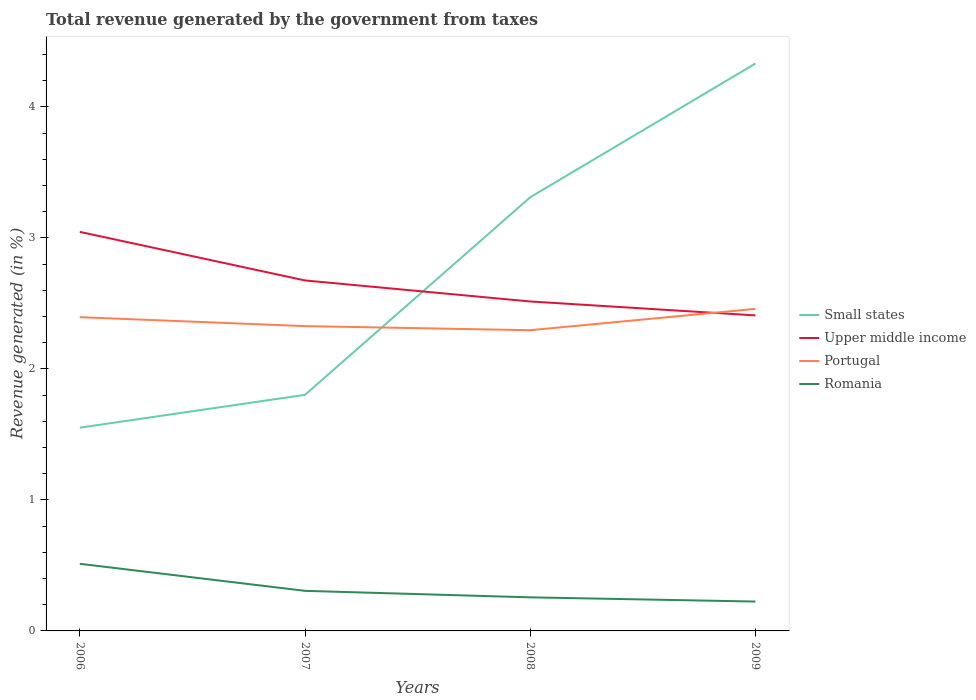Across all years, what is the maximum total revenue generated in Portugal?
Offer a terse response. 2.3. What is the total total revenue generated in Portugal in the graph?
Keep it short and to the point. -0.06. What is the difference between the highest and the second highest total revenue generated in Small states?
Offer a terse response. 2.78. What is the difference between the highest and the lowest total revenue generated in Romania?
Ensure brevity in your answer.  1. Is the total revenue generated in Upper middle income strictly greater than the total revenue generated in Romania over the years?
Your answer should be compact. No. What is the difference between two consecutive major ticks on the Y-axis?
Offer a very short reply. 1. Does the graph contain any zero values?
Your response must be concise. No. Does the graph contain grids?
Your answer should be very brief. No. Where does the legend appear in the graph?
Your answer should be very brief. Center right. How many legend labels are there?
Your answer should be compact. 4. How are the legend labels stacked?
Ensure brevity in your answer.  Vertical. What is the title of the graph?
Your response must be concise. Total revenue generated by the government from taxes. Does "Faeroe Islands" appear as one of the legend labels in the graph?
Your answer should be very brief. No. What is the label or title of the Y-axis?
Offer a very short reply. Revenue generated (in %). What is the Revenue generated (in %) of Small states in 2006?
Provide a succinct answer. 1.55. What is the Revenue generated (in %) of Upper middle income in 2006?
Give a very brief answer. 3.05. What is the Revenue generated (in %) of Portugal in 2006?
Keep it short and to the point. 2.39. What is the Revenue generated (in %) in Romania in 2006?
Your answer should be very brief. 0.51. What is the Revenue generated (in %) of Small states in 2007?
Keep it short and to the point. 1.8. What is the Revenue generated (in %) in Upper middle income in 2007?
Your answer should be very brief. 2.68. What is the Revenue generated (in %) in Portugal in 2007?
Give a very brief answer. 2.33. What is the Revenue generated (in %) of Romania in 2007?
Your answer should be very brief. 0.31. What is the Revenue generated (in %) in Small states in 2008?
Your response must be concise. 3.31. What is the Revenue generated (in %) of Upper middle income in 2008?
Keep it short and to the point. 2.51. What is the Revenue generated (in %) of Portugal in 2008?
Your answer should be very brief. 2.3. What is the Revenue generated (in %) in Romania in 2008?
Offer a very short reply. 0.26. What is the Revenue generated (in %) in Small states in 2009?
Offer a terse response. 4.33. What is the Revenue generated (in %) of Upper middle income in 2009?
Offer a very short reply. 2.41. What is the Revenue generated (in %) of Portugal in 2009?
Your answer should be very brief. 2.46. What is the Revenue generated (in %) in Romania in 2009?
Your response must be concise. 0.22. Across all years, what is the maximum Revenue generated (in %) of Small states?
Your response must be concise. 4.33. Across all years, what is the maximum Revenue generated (in %) of Upper middle income?
Make the answer very short. 3.05. Across all years, what is the maximum Revenue generated (in %) in Portugal?
Your answer should be very brief. 2.46. Across all years, what is the maximum Revenue generated (in %) in Romania?
Give a very brief answer. 0.51. Across all years, what is the minimum Revenue generated (in %) of Small states?
Your answer should be compact. 1.55. Across all years, what is the minimum Revenue generated (in %) of Upper middle income?
Give a very brief answer. 2.41. Across all years, what is the minimum Revenue generated (in %) of Portugal?
Keep it short and to the point. 2.3. Across all years, what is the minimum Revenue generated (in %) in Romania?
Your answer should be compact. 0.22. What is the total Revenue generated (in %) in Small states in the graph?
Your answer should be very brief. 10.99. What is the total Revenue generated (in %) in Upper middle income in the graph?
Provide a short and direct response. 10.64. What is the total Revenue generated (in %) of Portugal in the graph?
Provide a succinct answer. 9.47. What is the total Revenue generated (in %) of Romania in the graph?
Your answer should be compact. 1.3. What is the difference between the Revenue generated (in %) of Small states in 2006 and that in 2007?
Your answer should be very brief. -0.25. What is the difference between the Revenue generated (in %) in Upper middle income in 2006 and that in 2007?
Keep it short and to the point. 0.37. What is the difference between the Revenue generated (in %) in Portugal in 2006 and that in 2007?
Your answer should be compact. 0.07. What is the difference between the Revenue generated (in %) in Romania in 2006 and that in 2007?
Give a very brief answer. 0.21. What is the difference between the Revenue generated (in %) of Small states in 2006 and that in 2008?
Give a very brief answer. -1.76. What is the difference between the Revenue generated (in %) of Upper middle income in 2006 and that in 2008?
Give a very brief answer. 0.53. What is the difference between the Revenue generated (in %) of Portugal in 2006 and that in 2008?
Keep it short and to the point. 0.1. What is the difference between the Revenue generated (in %) in Romania in 2006 and that in 2008?
Keep it short and to the point. 0.26. What is the difference between the Revenue generated (in %) in Small states in 2006 and that in 2009?
Your response must be concise. -2.78. What is the difference between the Revenue generated (in %) in Upper middle income in 2006 and that in 2009?
Your answer should be compact. 0.64. What is the difference between the Revenue generated (in %) of Portugal in 2006 and that in 2009?
Provide a succinct answer. -0.06. What is the difference between the Revenue generated (in %) in Romania in 2006 and that in 2009?
Provide a succinct answer. 0.29. What is the difference between the Revenue generated (in %) in Small states in 2007 and that in 2008?
Give a very brief answer. -1.51. What is the difference between the Revenue generated (in %) in Upper middle income in 2007 and that in 2008?
Keep it short and to the point. 0.16. What is the difference between the Revenue generated (in %) of Portugal in 2007 and that in 2008?
Your answer should be compact. 0.03. What is the difference between the Revenue generated (in %) in Romania in 2007 and that in 2008?
Offer a very short reply. 0.05. What is the difference between the Revenue generated (in %) in Small states in 2007 and that in 2009?
Offer a very short reply. -2.53. What is the difference between the Revenue generated (in %) of Upper middle income in 2007 and that in 2009?
Ensure brevity in your answer.  0.27. What is the difference between the Revenue generated (in %) in Portugal in 2007 and that in 2009?
Keep it short and to the point. -0.13. What is the difference between the Revenue generated (in %) in Romania in 2007 and that in 2009?
Keep it short and to the point. 0.08. What is the difference between the Revenue generated (in %) in Small states in 2008 and that in 2009?
Ensure brevity in your answer.  -1.02. What is the difference between the Revenue generated (in %) in Upper middle income in 2008 and that in 2009?
Make the answer very short. 0.11. What is the difference between the Revenue generated (in %) in Portugal in 2008 and that in 2009?
Ensure brevity in your answer.  -0.16. What is the difference between the Revenue generated (in %) of Romania in 2008 and that in 2009?
Your answer should be compact. 0.03. What is the difference between the Revenue generated (in %) of Small states in 2006 and the Revenue generated (in %) of Upper middle income in 2007?
Give a very brief answer. -1.12. What is the difference between the Revenue generated (in %) of Small states in 2006 and the Revenue generated (in %) of Portugal in 2007?
Provide a succinct answer. -0.78. What is the difference between the Revenue generated (in %) of Small states in 2006 and the Revenue generated (in %) of Romania in 2007?
Offer a terse response. 1.25. What is the difference between the Revenue generated (in %) in Upper middle income in 2006 and the Revenue generated (in %) in Portugal in 2007?
Give a very brief answer. 0.72. What is the difference between the Revenue generated (in %) in Upper middle income in 2006 and the Revenue generated (in %) in Romania in 2007?
Offer a very short reply. 2.74. What is the difference between the Revenue generated (in %) of Portugal in 2006 and the Revenue generated (in %) of Romania in 2007?
Provide a succinct answer. 2.09. What is the difference between the Revenue generated (in %) in Small states in 2006 and the Revenue generated (in %) in Upper middle income in 2008?
Provide a succinct answer. -0.96. What is the difference between the Revenue generated (in %) of Small states in 2006 and the Revenue generated (in %) of Portugal in 2008?
Your answer should be very brief. -0.74. What is the difference between the Revenue generated (in %) of Small states in 2006 and the Revenue generated (in %) of Romania in 2008?
Ensure brevity in your answer.  1.3. What is the difference between the Revenue generated (in %) in Upper middle income in 2006 and the Revenue generated (in %) in Portugal in 2008?
Ensure brevity in your answer.  0.75. What is the difference between the Revenue generated (in %) of Upper middle income in 2006 and the Revenue generated (in %) of Romania in 2008?
Offer a terse response. 2.79. What is the difference between the Revenue generated (in %) of Portugal in 2006 and the Revenue generated (in %) of Romania in 2008?
Provide a succinct answer. 2.14. What is the difference between the Revenue generated (in %) of Small states in 2006 and the Revenue generated (in %) of Upper middle income in 2009?
Provide a succinct answer. -0.86. What is the difference between the Revenue generated (in %) of Small states in 2006 and the Revenue generated (in %) of Portugal in 2009?
Provide a short and direct response. -0.91. What is the difference between the Revenue generated (in %) of Small states in 2006 and the Revenue generated (in %) of Romania in 2009?
Provide a succinct answer. 1.33. What is the difference between the Revenue generated (in %) of Upper middle income in 2006 and the Revenue generated (in %) of Portugal in 2009?
Your answer should be very brief. 0.59. What is the difference between the Revenue generated (in %) in Upper middle income in 2006 and the Revenue generated (in %) in Romania in 2009?
Your answer should be compact. 2.82. What is the difference between the Revenue generated (in %) in Portugal in 2006 and the Revenue generated (in %) in Romania in 2009?
Make the answer very short. 2.17. What is the difference between the Revenue generated (in %) of Small states in 2007 and the Revenue generated (in %) of Upper middle income in 2008?
Your answer should be compact. -0.71. What is the difference between the Revenue generated (in %) in Small states in 2007 and the Revenue generated (in %) in Portugal in 2008?
Your answer should be very brief. -0.49. What is the difference between the Revenue generated (in %) of Small states in 2007 and the Revenue generated (in %) of Romania in 2008?
Keep it short and to the point. 1.55. What is the difference between the Revenue generated (in %) of Upper middle income in 2007 and the Revenue generated (in %) of Portugal in 2008?
Give a very brief answer. 0.38. What is the difference between the Revenue generated (in %) in Upper middle income in 2007 and the Revenue generated (in %) in Romania in 2008?
Give a very brief answer. 2.42. What is the difference between the Revenue generated (in %) of Portugal in 2007 and the Revenue generated (in %) of Romania in 2008?
Keep it short and to the point. 2.07. What is the difference between the Revenue generated (in %) of Small states in 2007 and the Revenue generated (in %) of Upper middle income in 2009?
Provide a short and direct response. -0.61. What is the difference between the Revenue generated (in %) in Small states in 2007 and the Revenue generated (in %) in Portugal in 2009?
Your answer should be compact. -0.66. What is the difference between the Revenue generated (in %) in Small states in 2007 and the Revenue generated (in %) in Romania in 2009?
Your answer should be compact. 1.58. What is the difference between the Revenue generated (in %) in Upper middle income in 2007 and the Revenue generated (in %) in Portugal in 2009?
Ensure brevity in your answer.  0.22. What is the difference between the Revenue generated (in %) in Upper middle income in 2007 and the Revenue generated (in %) in Romania in 2009?
Keep it short and to the point. 2.45. What is the difference between the Revenue generated (in %) in Portugal in 2007 and the Revenue generated (in %) in Romania in 2009?
Offer a terse response. 2.1. What is the difference between the Revenue generated (in %) of Small states in 2008 and the Revenue generated (in %) of Upper middle income in 2009?
Offer a terse response. 0.9. What is the difference between the Revenue generated (in %) of Small states in 2008 and the Revenue generated (in %) of Portugal in 2009?
Your response must be concise. 0.85. What is the difference between the Revenue generated (in %) of Small states in 2008 and the Revenue generated (in %) of Romania in 2009?
Ensure brevity in your answer.  3.09. What is the difference between the Revenue generated (in %) of Upper middle income in 2008 and the Revenue generated (in %) of Portugal in 2009?
Make the answer very short. 0.06. What is the difference between the Revenue generated (in %) in Upper middle income in 2008 and the Revenue generated (in %) in Romania in 2009?
Provide a succinct answer. 2.29. What is the difference between the Revenue generated (in %) in Portugal in 2008 and the Revenue generated (in %) in Romania in 2009?
Provide a short and direct response. 2.07. What is the average Revenue generated (in %) of Small states per year?
Keep it short and to the point. 2.75. What is the average Revenue generated (in %) in Upper middle income per year?
Offer a terse response. 2.66. What is the average Revenue generated (in %) in Portugal per year?
Your response must be concise. 2.37. What is the average Revenue generated (in %) of Romania per year?
Offer a very short reply. 0.32. In the year 2006, what is the difference between the Revenue generated (in %) in Small states and Revenue generated (in %) in Upper middle income?
Provide a short and direct response. -1.49. In the year 2006, what is the difference between the Revenue generated (in %) of Small states and Revenue generated (in %) of Portugal?
Provide a short and direct response. -0.84. In the year 2006, what is the difference between the Revenue generated (in %) in Small states and Revenue generated (in %) in Romania?
Make the answer very short. 1.04. In the year 2006, what is the difference between the Revenue generated (in %) of Upper middle income and Revenue generated (in %) of Portugal?
Provide a succinct answer. 0.65. In the year 2006, what is the difference between the Revenue generated (in %) in Upper middle income and Revenue generated (in %) in Romania?
Provide a succinct answer. 2.53. In the year 2006, what is the difference between the Revenue generated (in %) in Portugal and Revenue generated (in %) in Romania?
Your response must be concise. 1.88. In the year 2007, what is the difference between the Revenue generated (in %) of Small states and Revenue generated (in %) of Upper middle income?
Provide a short and direct response. -0.87. In the year 2007, what is the difference between the Revenue generated (in %) in Small states and Revenue generated (in %) in Portugal?
Ensure brevity in your answer.  -0.52. In the year 2007, what is the difference between the Revenue generated (in %) of Small states and Revenue generated (in %) of Romania?
Provide a succinct answer. 1.5. In the year 2007, what is the difference between the Revenue generated (in %) in Upper middle income and Revenue generated (in %) in Portugal?
Offer a very short reply. 0.35. In the year 2007, what is the difference between the Revenue generated (in %) in Upper middle income and Revenue generated (in %) in Romania?
Provide a succinct answer. 2.37. In the year 2007, what is the difference between the Revenue generated (in %) of Portugal and Revenue generated (in %) of Romania?
Your answer should be compact. 2.02. In the year 2008, what is the difference between the Revenue generated (in %) in Small states and Revenue generated (in %) in Upper middle income?
Make the answer very short. 0.8. In the year 2008, what is the difference between the Revenue generated (in %) of Small states and Revenue generated (in %) of Portugal?
Provide a short and direct response. 1.01. In the year 2008, what is the difference between the Revenue generated (in %) of Small states and Revenue generated (in %) of Romania?
Offer a very short reply. 3.05. In the year 2008, what is the difference between the Revenue generated (in %) in Upper middle income and Revenue generated (in %) in Portugal?
Ensure brevity in your answer.  0.22. In the year 2008, what is the difference between the Revenue generated (in %) of Upper middle income and Revenue generated (in %) of Romania?
Make the answer very short. 2.26. In the year 2008, what is the difference between the Revenue generated (in %) of Portugal and Revenue generated (in %) of Romania?
Offer a very short reply. 2.04. In the year 2009, what is the difference between the Revenue generated (in %) in Small states and Revenue generated (in %) in Upper middle income?
Your answer should be very brief. 1.92. In the year 2009, what is the difference between the Revenue generated (in %) of Small states and Revenue generated (in %) of Portugal?
Offer a terse response. 1.87. In the year 2009, what is the difference between the Revenue generated (in %) in Small states and Revenue generated (in %) in Romania?
Provide a succinct answer. 4.11. In the year 2009, what is the difference between the Revenue generated (in %) of Upper middle income and Revenue generated (in %) of Portugal?
Ensure brevity in your answer.  -0.05. In the year 2009, what is the difference between the Revenue generated (in %) in Upper middle income and Revenue generated (in %) in Romania?
Provide a succinct answer. 2.18. In the year 2009, what is the difference between the Revenue generated (in %) of Portugal and Revenue generated (in %) of Romania?
Your response must be concise. 2.23. What is the ratio of the Revenue generated (in %) in Small states in 2006 to that in 2007?
Make the answer very short. 0.86. What is the ratio of the Revenue generated (in %) of Upper middle income in 2006 to that in 2007?
Offer a terse response. 1.14. What is the ratio of the Revenue generated (in %) of Portugal in 2006 to that in 2007?
Keep it short and to the point. 1.03. What is the ratio of the Revenue generated (in %) of Romania in 2006 to that in 2007?
Offer a very short reply. 1.68. What is the ratio of the Revenue generated (in %) in Small states in 2006 to that in 2008?
Provide a short and direct response. 0.47. What is the ratio of the Revenue generated (in %) of Upper middle income in 2006 to that in 2008?
Ensure brevity in your answer.  1.21. What is the ratio of the Revenue generated (in %) of Portugal in 2006 to that in 2008?
Ensure brevity in your answer.  1.04. What is the ratio of the Revenue generated (in %) in Romania in 2006 to that in 2008?
Keep it short and to the point. 2. What is the ratio of the Revenue generated (in %) of Small states in 2006 to that in 2009?
Give a very brief answer. 0.36. What is the ratio of the Revenue generated (in %) of Upper middle income in 2006 to that in 2009?
Offer a very short reply. 1.26. What is the ratio of the Revenue generated (in %) in Portugal in 2006 to that in 2009?
Offer a terse response. 0.97. What is the ratio of the Revenue generated (in %) in Romania in 2006 to that in 2009?
Your answer should be compact. 2.29. What is the ratio of the Revenue generated (in %) of Small states in 2007 to that in 2008?
Your answer should be very brief. 0.54. What is the ratio of the Revenue generated (in %) in Upper middle income in 2007 to that in 2008?
Offer a terse response. 1.06. What is the ratio of the Revenue generated (in %) of Portugal in 2007 to that in 2008?
Make the answer very short. 1.01. What is the ratio of the Revenue generated (in %) of Romania in 2007 to that in 2008?
Provide a succinct answer. 1.19. What is the ratio of the Revenue generated (in %) in Small states in 2007 to that in 2009?
Make the answer very short. 0.42. What is the ratio of the Revenue generated (in %) in Upper middle income in 2007 to that in 2009?
Provide a succinct answer. 1.11. What is the ratio of the Revenue generated (in %) in Portugal in 2007 to that in 2009?
Your answer should be compact. 0.95. What is the ratio of the Revenue generated (in %) in Romania in 2007 to that in 2009?
Give a very brief answer. 1.36. What is the ratio of the Revenue generated (in %) of Small states in 2008 to that in 2009?
Offer a very short reply. 0.76. What is the ratio of the Revenue generated (in %) in Upper middle income in 2008 to that in 2009?
Give a very brief answer. 1.04. What is the ratio of the Revenue generated (in %) of Portugal in 2008 to that in 2009?
Your response must be concise. 0.93. What is the ratio of the Revenue generated (in %) of Romania in 2008 to that in 2009?
Make the answer very short. 1.14. What is the difference between the highest and the second highest Revenue generated (in %) of Small states?
Give a very brief answer. 1.02. What is the difference between the highest and the second highest Revenue generated (in %) of Upper middle income?
Ensure brevity in your answer.  0.37. What is the difference between the highest and the second highest Revenue generated (in %) in Portugal?
Provide a short and direct response. 0.06. What is the difference between the highest and the second highest Revenue generated (in %) in Romania?
Provide a short and direct response. 0.21. What is the difference between the highest and the lowest Revenue generated (in %) in Small states?
Your answer should be compact. 2.78. What is the difference between the highest and the lowest Revenue generated (in %) of Upper middle income?
Your answer should be compact. 0.64. What is the difference between the highest and the lowest Revenue generated (in %) of Portugal?
Give a very brief answer. 0.16. What is the difference between the highest and the lowest Revenue generated (in %) in Romania?
Make the answer very short. 0.29. 